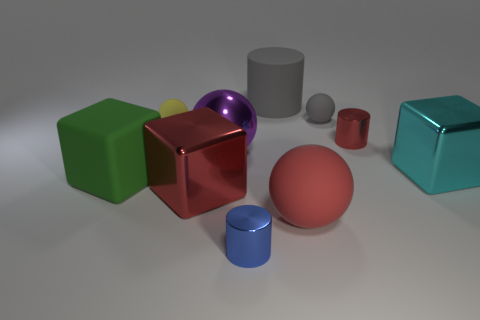Which objects in the image look metallic? The objects that appear to have a metallic look are the red cube near the center and the teal cube on the right side of the image. Their surfaces reflect light in a way that is characteristic of metallic materials. 